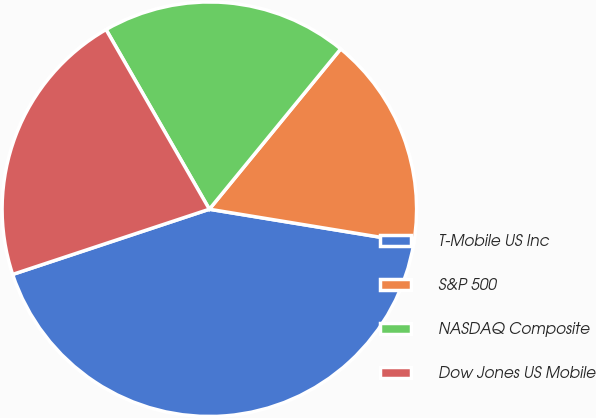<chart> <loc_0><loc_0><loc_500><loc_500><pie_chart><fcel>T-Mobile US Inc<fcel>S&P 500<fcel>NASDAQ Composite<fcel>Dow Jones US Mobile<nl><fcel>42.32%<fcel>16.66%<fcel>19.23%<fcel>21.79%<nl></chart> 